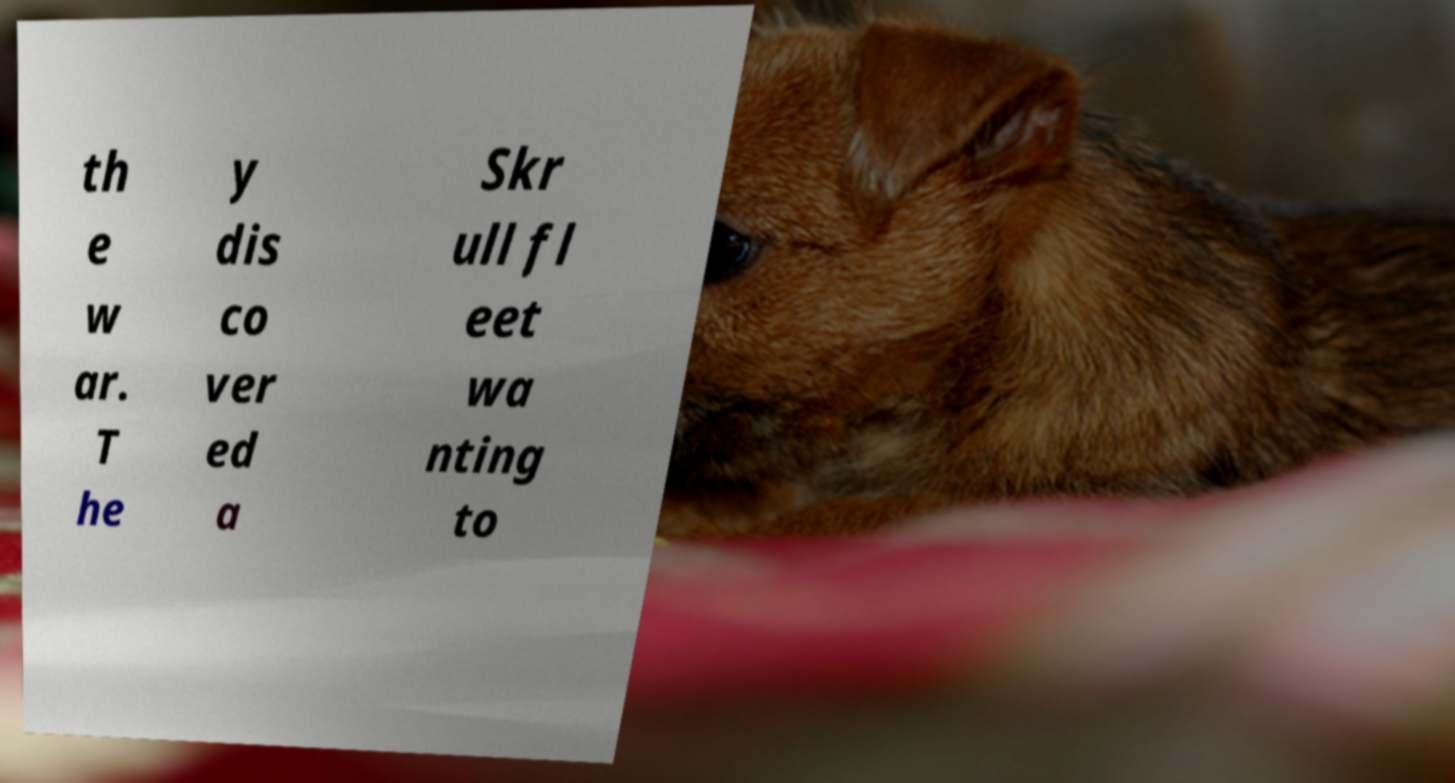For documentation purposes, I need the text within this image transcribed. Could you provide that? th e w ar. T he y dis co ver ed a Skr ull fl eet wa nting to 